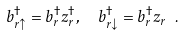Convert formula to latex. <formula><loc_0><loc_0><loc_500><loc_500>b ^ { \dagger } _ { r \uparrow } = b ^ { \dagger } _ { r } z ^ { \dagger } _ { r } , \ \ b ^ { \dagger } _ { r \downarrow } = b ^ { \dagger } _ { r } z _ { r } \ .</formula> 